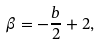<formula> <loc_0><loc_0><loc_500><loc_500>\beta = - \frac { b } { 2 } + 2 ,</formula> 